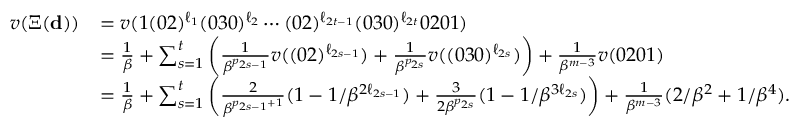Convert formula to latex. <formula><loc_0><loc_0><loc_500><loc_500>\begin{array} { r l } { v ( \Xi ( \mathbf d ) ) } & { = v ( 1 ( 0 2 ) ^ { \ell _ { 1 } } ( 0 3 0 ) ^ { \ell _ { 2 } } \cdots ( 0 2 ) ^ { \ell _ { 2 t - 1 } } ( 0 3 0 ) ^ { \ell _ { 2 t } } 0 2 0 1 ) } \\ & { = \frac { 1 } { \beta } + \sum _ { s = 1 } ^ { t } \left ( \frac { 1 } \beta ^ { p _ { 2 s - 1 } } } v ( ( 0 2 ) ^ { \ell _ { 2 s - 1 } } ) + \frac { 1 } \beta ^ { p _ { 2 s } } } v ( ( 0 3 0 ) ^ { \ell _ { 2 s } } ) \right ) + \frac { 1 } \beta ^ { m - 3 } } v ( 0 2 0 1 ) } \\ & { = \frac { 1 } { \beta } + \sum _ { s = 1 } ^ { t } \left ( \frac { 2 } { \beta ^ { p _ { 2 s - 1 } + 1 } } ( 1 - 1 / \beta ^ { 2 \ell _ { 2 s - 1 } } ) + \frac { 3 } 2 \beta ^ { p _ { 2 s } } } ( 1 - 1 / \beta ^ { 3 \ell _ { 2 s } } ) \right ) + \frac { 1 } \beta ^ { m - 3 } } ( 2 / \beta ^ { 2 } + 1 / \beta ^ { 4 } ) . } \end{array}</formula> 